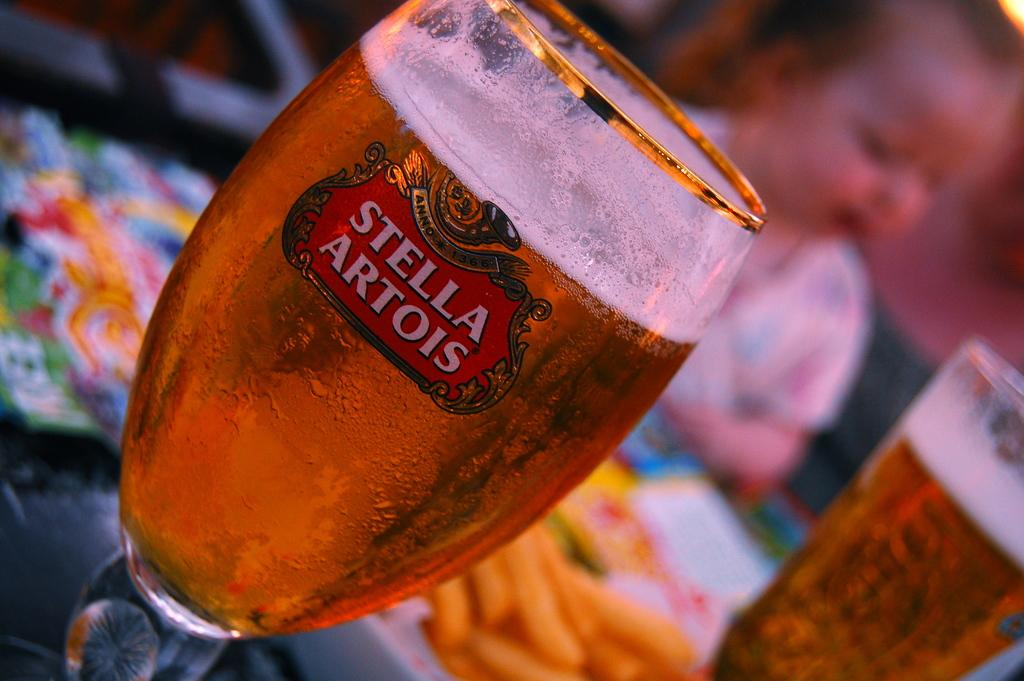<image>
Describe the image concisely. a stella artois glass is sitting in the table 